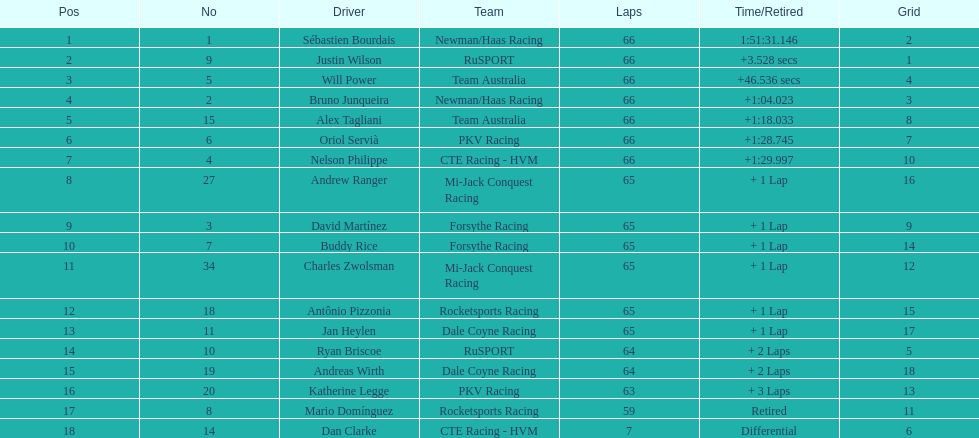How many drivers did not make more than 60 laps? 2. 